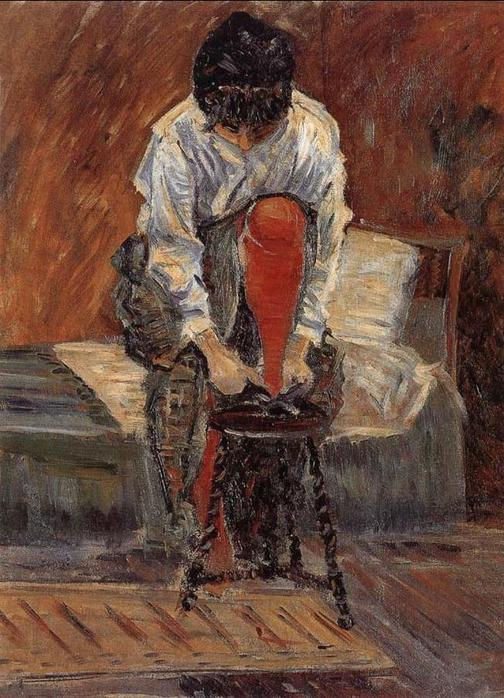Could you imagine a story behind this moment? Absolutely. Picture a young woman who has just returned from a bustling day in the city. She sits down in her modest, cozy room to remove her shoes, reflecting on the myriad of interactions and events she experienced. Perhaps she met someone interesting, or she faced a moment of tension, and now, in the solitude of her room, she's replaying those moments in her mind, mulling over her feelings and thoughts. 